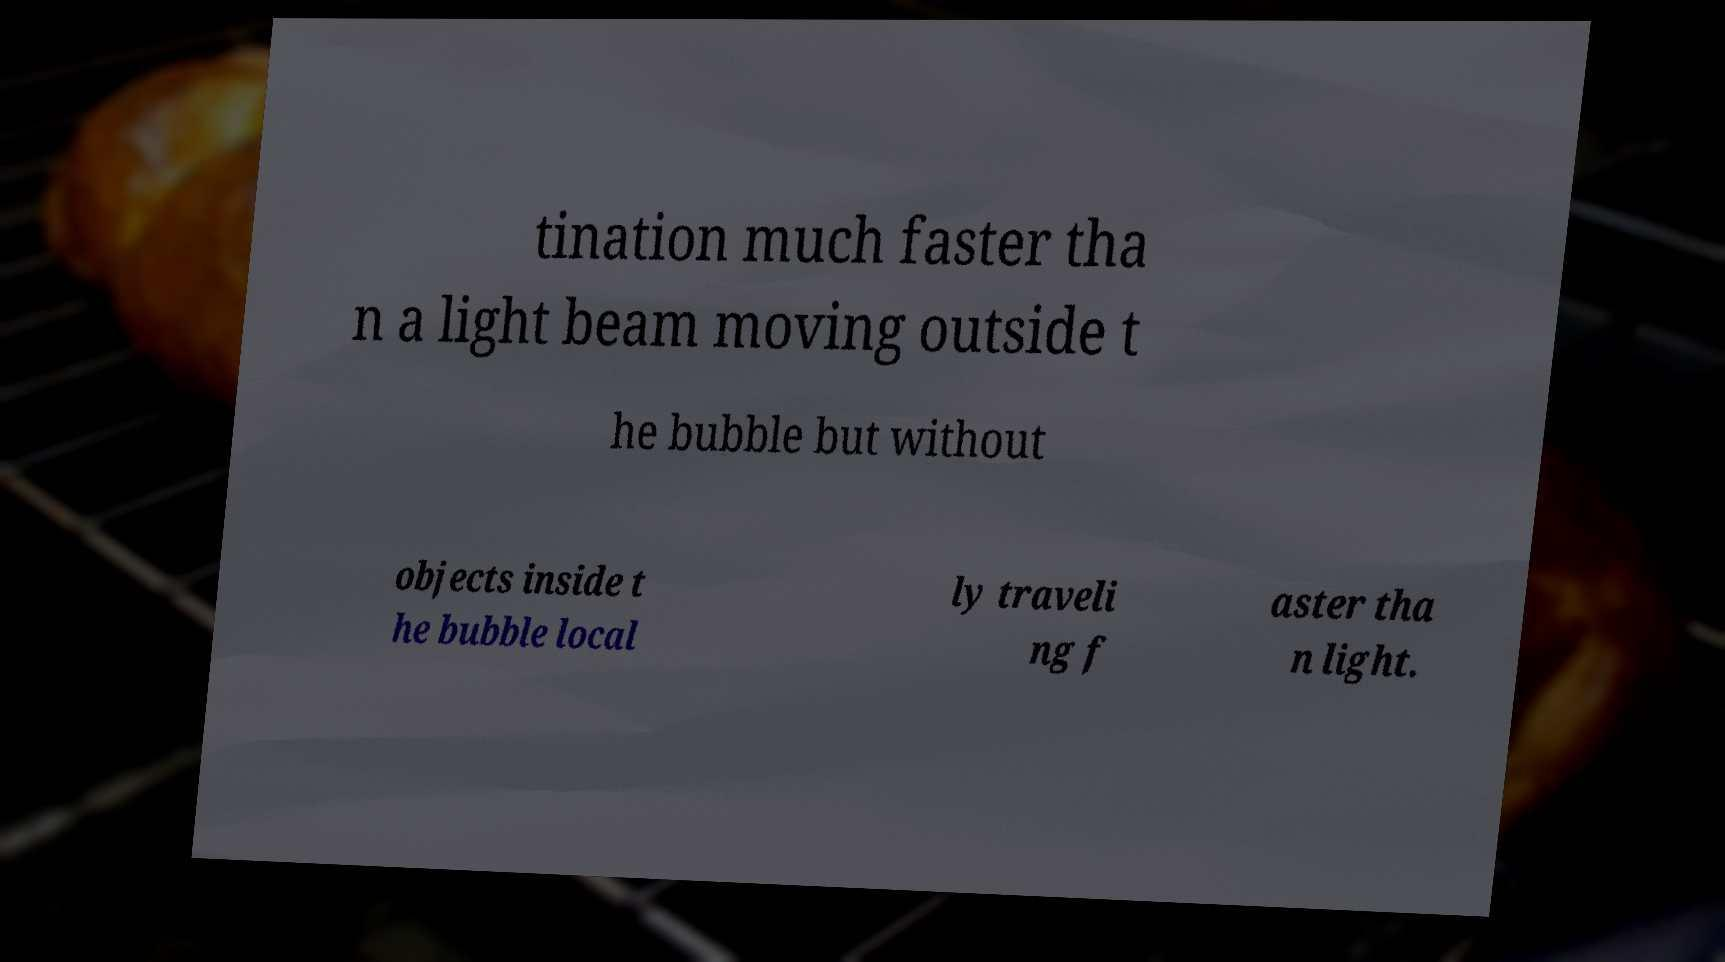Can you read and provide the text displayed in the image?This photo seems to have some interesting text. Can you extract and type it out for me? tination much faster tha n a light beam moving outside t he bubble but without objects inside t he bubble local ly traveli ng f aster tha n light. 